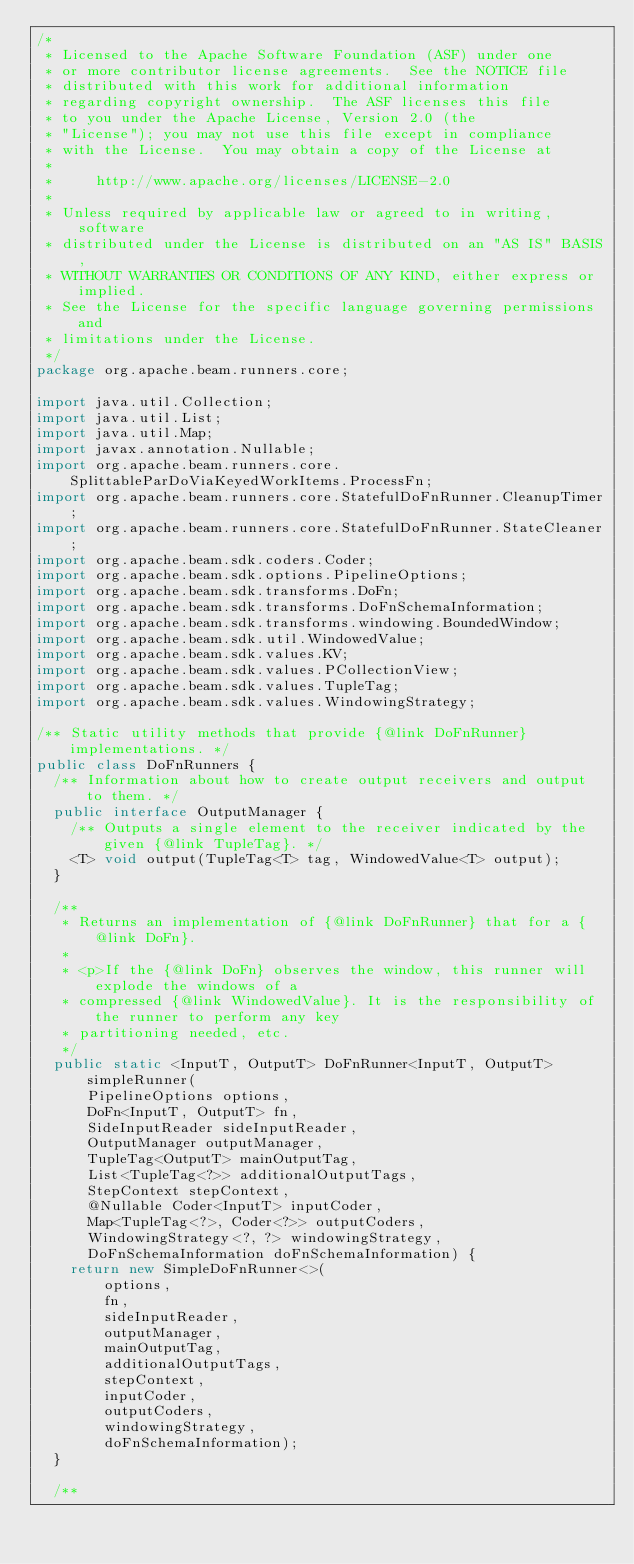<code> <loc_0><loc_0><loc_500><loc_500><_Java_>/*
 * Licensed to the Apache Software Foundation (ASF) under one
 * or more contributor license agreements.  See the NOTICE file
 * distributed with this work for additional information
 * regarding copyright ownership.  The ASF licenses this file
 * to you under the Apache License, Version 2.0 (the
 * "License"); you may not use this file except in compliance
 * with the License.  You may obtain a copy of the License at
 *
 *     http://www.apache.org/licenses/LICENSE-2.0
 *
 * Unless required by applicable law or agreed to in writing, software
 * distributed under the License is distributed on an "AS IS" BASIS,
 * WITHOUT WARRANTIES OR CONDITIONS OF ANY KIND, either express or implied.
 * See the License for the specific language governing permissions and
 * limitations under the License.
 */
package org.apache.beam.runners.core;

import java.util.Collection;
import java.util.List;
import java.util.Map;
import javax.annotation.Nullable;
import org.apache.beam.runners.core.SplittableParDoViaKeyedWorkItems.ProcessFn;
import org.apache.beam.runners.core.StatefulDoFnRunner.CleanupTimer;
import org.apache.beam.runners.core.StatefulDoFnRunner.StateCleaner;
import org.apache.beam.sdk.coders.Coder;
import org.apache.beam.sdk.options.PipelineOptions;
import org.apache.beam.sdk.transforms.DoFn;
import org.apache.beam.sdk.transforms.DoFnSchemaInformation;
import org.apache.beam.sdk.transforms.windowing.BoundedWindow;
import org.apache.beam.sdk.util.WindowedValue;
import org.apache.beam.sdk.values.KV;
import org.apache.beam.sdk.values.PCollectionView;
import org.apache.beam.sdk.values.TupleTag;
import org.apache.beam.sdk.values.WindowingStrategy;

/** Static utility methods that provide {@link DoFnRunner} implementations. */
public class DoFnRunners {
  /** Information about how to create output receivers and output to them. */
  public interface OutputManager {
    /** Outputs a single element to the receiver indicated by the given {@link TupleTag}. */
    <T> void output(TupleTag<T> tag, WindowedValue<T> output);
  }

  /**
   * Returns an implementation of {@link DoFnRunner} that for a {@link DoFn}.
   *
   * <p>If the {@link DoFn} observes the window, this runner will explode the windows of a
   * compressed {@link WindowedValue}. It is the responsibility of the runner to perform any key
   * partitioning needed, etc.
   */
  public static <InputT, OutputT> DoFnRunner<InputT, OutputT> simpleRunner(
      PipelineOptions options,
      DoFn<InputT, OutputT> fn,
      SideInputReader sideInputReader,
      OutputManager outputManager,
      TupleTag<OutputT> mainOutputTag,
      List<TupleTag<?>> additionalOutputTags,
      StepContext stepContext,
      @Nullable Coder<InputT> inputCoder,
      Map<TupleTag<?>, Coder<?>> outputCoders,
      WindowingStrategy<?, ?> windowingStrategy,
      DoFnSchemaInformation doFnSchemaInformation) {
    return new SimpleDoFnRunner<>(
        options,
        fn,
        sideInputReader,
        outputManager,
        mainOutputTag,
        additionalOutputTags,
        stepContext,
        inputCoder,
        outputCoders,
        windowingStrategy,
        doFnSchemaInformation);
  }

  /**</code> 